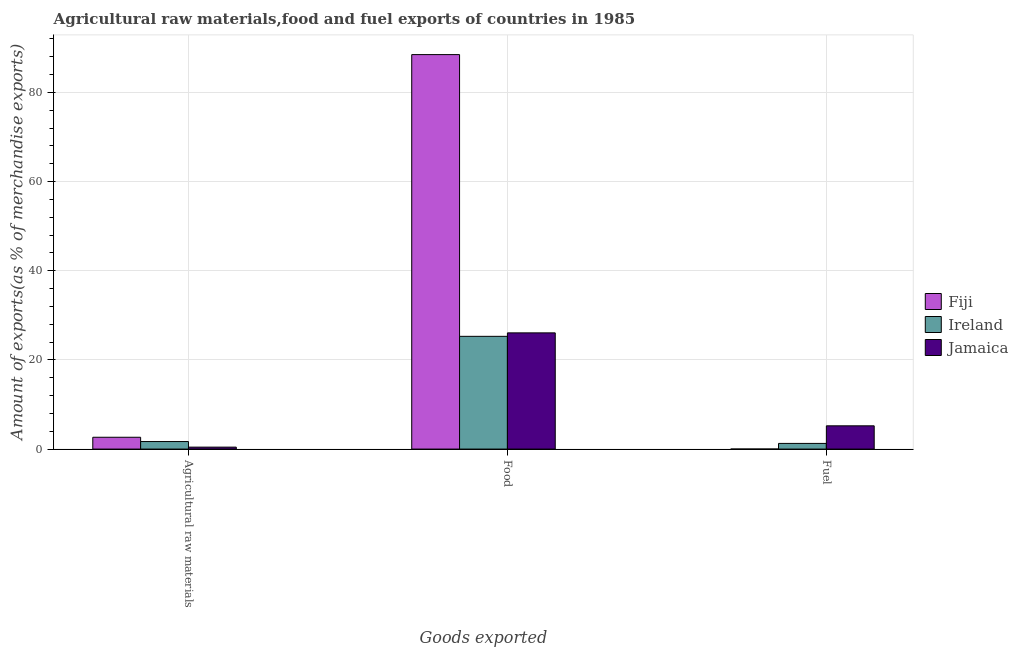How many different coloured bars are there?
Your answer should be compact. 3. How many groups of bars are there?
Offer a terse response. 3. Are the number of bars per tick equal to the number of legend labels?
Ensure brevity in your answer.  Yes. How many bars are there on the 3rd tick from the left?
Your response must be concise. 3. What is the label of the 3rd group of bars from the left?
Provide a short and direct response. Fuel. What is the percentage of raw materials exports in Jamaica?
Your response must be concise. 0.44. Across all countries, what is the maximum percentage of fuel exports?
Your answer should be compact. 5.22. Across all countries, what is the minimum percentage of fuel exports?
Offer a terse response. 0. In which country was the percentage of food exports maximum?
Make the answer very short. Fiji. In which country was the percentage of raw materials exports minimum?
Give a very brief answer. Jamaica. What is the total percentage of fuel exports in the graph?
Keep it short and to the point. 6.49. What is the difference between the percentage of raw materials exports in Jamaica and that in Ireland?
Make the answer very short. -1.26. What is the difference between the percentage of fuel exports in Ireland and the percentage of raw materials exports in Fiji?
Ensure brevity in your answer.  -1.38. What is the average percentage of food exports per country?
Offer a terse response. 46.6. What is the difference between the percentage of raw materials exports and percentage of fuel exports in Ireland?
Provide a short and direct response. 0.42. In how many countries, is the percentage of raw materials exports greater than 8 %?
Ensure brevity in your answer.  0. What is the ratio of the percentage of raw materials exports in Ireland to that in Fiji?
Your answer should be compact. 0.64. Is the percentage of fuel exports in Fiji less than that in Ireland?
Make the answer very short. Yes. Is the difference between the percentage of food exports in Ireland and Fiji greater than the difference between the percentage of fuel exports in Ireland and Fiji?
Your answer should be compact. No. What is the difference between the highest and the second highest percentage of raw materials exports?
Offer a terse response. 0.96. What is the difference between the highest and the lowest percentage of food exports?
Your answer should be very brief. 63.18. What does the 2nd bar from the left in Agricultural raw materials represents?
Your response must be concise. Ireland. What does the 2nd bar from the right in Fuel represents?
Keep it short and to the point. Ireland. Are all the bars in the graph horizontal?
Provide a succinct answer. No. Are the values on the major ticks of Y-axis written in scientific E-notation?
Provide a succinct answer. No. Does the graph contain any zero values?
Offer a very short reply. No. How many legend labels are there?
Make the answer very short. 3. How are the legend labels stacked?
Offer a very short reply. Vertical. What is the title of the graph?
Provide a short and direct response. Agricultural raw materials,food and fuel exports of countries in 1985. Does "Argentina" appear as one of the legend labels in the graph?
Provide a short and direct response. No. What is the label or title of the X-axis?
Your answer should be compact. Goods exported. What is the label or title of the Y-axis?
Provide a succinct answer. Amount of exports(as % of merchandise exports). What is the Amount of exports(as % of merchandise exports) of Fiji in Agricultural raw materials?
Provide a succinct answer. 2.65. What is the Amount of exports(as % of merchandise exports) in Ireland in Agricultural raw materials?
Make the answer very short. 1.69. What is the Amount of exports(as % of merchandise exports) of Jamaica in Agricultural raw materials?
Ensure brevity in your answer.  0.44. What is the Amount of exports(as % of merchandise exports) of Fiji in Food?
Provide a succinct answer. 88.47. What is the Amount of exports(as % of merchandise exports) of Ireland in Food?
Your response must be concise. 25.28. What is the Amount of exports(as % of merchandise exports) in Jamaica in Food?
Provide a short and direct response. 26.06. What is the Amount of exports(as % of merchandise exports) in Fiji in Fuel?
Ensure brevity in your answer.  0. What is the Amount of exports(as % of merchandise exports) in Ireland in Fuel?
Your response must be concise. 1.27. What is the Amount of exports(as % of merchandise exports) in Jamaica in Fuel?
Make the answer very short. 5.22. Across all Goods exported, what is the maximum Amount of exports(as % of merchandise exports) of Fiji?
Make the answer very short. 88.47. Across all Goods exported, what is the maximum Amount of exports(as % of merchandise exports) of Ireland?
Keep it short and to the point. 25.28. Across all Goods exported, what is the maximum Amount of exports(as % of merchandise exports) in Jamaica?
Provide a short and direct response. 26.06. Across all Goods exported, what is the minimum Amount of exports(as % of merchandise exports) of Fiji?
Provide a short and direct response. 0. Across all Goods exported, what is the minimum Amount of exports(as % of merchandise exports) in Ireland?
Your answer should be compact. 1.27. Across all Goods exported, what is the minimum Amount of exports(as % of merchandise exports) of Jamaica?
Provide a succinct answer. 0.44. What is the total Amount of exports(as % of merchandise exports) of Fiji in the graph?
Make the answer very short. 91.12. What is the total Amount of exports(as % of merchandise exports) of Ireland in the graph?
Keep it short and to the point. 28.24. What is the total Amount of exports(as % of merchandise exports) of Jamaica in the graph?
Keep it short and to the point. 31.71. What is the difference between the Amount of exports(as % of merchandise exports) in Fiji in Agricultural raw materials and that in Food?
Your response must be concise. -85.82. What is the difference between the Amount of exports(as % of merchandise exports) of Ireland in Agricultural raw materials and that in Food?
Your answer should be very brief. -23.59. What is the difference between the Amount of exports(as % of merchandise exports) of Jamaica in Agricultural raw materials and that in Food?
Your answer should be compact. -25.62. What is the difference between the Amount of exports(as % of merchandise exports) in Fiji in Agricultural raw materials and that in Fuel?
Ensure brevity in your answer.  2.65. What is the difference between the Amount of exports(as % of merchandise exports) of Ireland in Agricultural raw materials and that in Fuel?
Offer a very short reply. 0.42. What is the difference between the Amount of exports(as % of merchandise exports) in Jamaica in Agricultural raw materials and that in Fuel?
Offer a terse response. -4.78. What is the difference between the Amount of exports(as % of merchandise exports) in Fiji in Food and that in Fuel?
Give a very brief answer. 88.47. What is the difference between the Amount of exports(as % of merchandise exports) of Ireland in Food and that in Fuel?
Offer a terse response. 24.01. What is the difference between the Amount of exports(as % of merchandise exports) of Jamaica in Food and that in Fuel?
Provide a short and direct response. 20.84. What is the difference between the Amount of exports(as % of merchandise exports) of Fiji in Agricultural raw materials and the Amount of exports(as % of merchandise exports) of Ireland in Food?
Provide a succinct answer. -22.63. What is the difference between the Amount of exports(as % of merchandise exports) of Fiji in Agricultural raw materials and the Amount of exports(as % of merchandise exports) of Jamaica in Food?
Provide a succinct answer. -23.41. What is the difference between the Amount of exports(as % of merchandise exports) of Ireland in Agricultural raw materials and the Amount of exports(as % of merchandise exports) of Jamaica in Food?
Your answer should be compact. -24.37. What is the difference between the Amount of exports(as % of merchandise exports) in Fiji in Agricultural raw materials and the Amount of exports(as % of merchandise exports) in Ireland in Fuel?
Your answer should be compact. 1.38. What is the difference between the Amount of exports(as % of merchandise exports) of Fiji in Agricultural raw materials and the Amount of exports(as % of merchandise exports) of Jamaica in Fuel?
Offer a very short reply. -2.56. What is the difference between the Amount of exports(as % of merchandise exports) in Ireland in Agricultural raw materials and the Amount of exports(as % of merchandise exports) in Jamaica in Fuel?
Give a very brief answer. -3.52. What is the difference between the Amount of exports(as % of merchandise exports) in Fiji in Food and the Amount of exports(as % of merchandise exports) in Ireland in Fuel?
Make the answer very short. 87.2. What is the difference between the Amount of exports(as % of merchandise exports) of Fiji in Food and the Amount of exports(as % of merchandise exports) of Jamaica in Fuel?
Your response must be concise. 83.25. What is the difference between the Amount of exports(as % of merchandise exports) in Ireland in Food and the Amount of exports(as % of merchandise exports) in Jamaica in Fuel?
Ensure brevity in your answer.  20.07. What is the average Amount of exports(as % of merchandise exports) of Fiji per Goods exported?
Your answer should be compact. 30.37. What is the average Amount of exports(as % of merchandise exports) of Ireland per Goods exported?
Your answer should be compact. 9.41. What is the average Amount of exports(as % of merchandise exports) in Jamaica per Goods exported?
Your answer should be compact. 10.57. What is the difference between the Amount of exports(as % of merchandise exports) in Fiji and Amount of exports(as % of merchandise exports) in Ireland in Agricultural raw materials?
Offer a terse response. 0.96. What is the difference between the Amount of exports(as % of merchandise exports) of Fiji and Amount of exports(as % of merchandise exports) of Jamaica in Agricultural raw materials?
Offer a very short reply. 2.22. What is the difference between the Amount of exports(as % of merchandise exports) in Ireland and Amount of exports(as % of merchandise exports) in Jamaica in Agricultural raw materials?
Offer a terse response. 1.26. What is the difference between the Amount of exports(as % of merchandise exports) of Fiji and Amount of exports(as % of merchandise exports) of Ireland in Food?
Your answer should be compact. 63.18. What is the difference between the Amount of exports(as % of merchandise exports) in Fiji and Amount of exports(as % of merchandise exports) in Jamaica in Food?
Your answer should be very brief. 62.41. What is the difference between the Amount of exports(as % of merchandise exports) of Ireland and Amount of exports(as % of merchandise exports) of Jamaica in Food?
Offer a terse response. -0.78. What is the difference between the Amount of exports(as % of merchandise exports) of Fiji and Amount of exports(as % of merchandise exports) of Ireland in Fuel?
Offer a very short reply. -1.27. What is the difference between the Amount of exports(as % of merchandise exports) in Fiji and Amount of exports(as % of merchandise exports) in Jamaica in Fuel?
Provide a short and direct response. -5.21. What is the difference between the Amount of exports(as % of merchandise exports) of Ireland and Amount of exports(as % of merchandise exports) of Jamaica in Fuel?
Give a very brief answer. -3.95. What is the ratio of the Amount of exports(as % of merchandise exports) in Fiji in Agricultural raw materials to that in Food?
Your answer should be very brief. 0.03. What is the ratio of the Amount of exports(as % of merchandise exports) in Ireland in Agricultural raw materials to that in Food?
Make the answer very short. 0.07. What is the ratio of the Amount of exports(as % of merchandise exports) in Jamaica in Agricultural raw materials to that in Food?
Your answer should be compact. 0.02. What is the ratio of the Amount of exports(as % of merchandise exports) in Fiji in Agricultural raw materials to that in Fuel?
Your answer should be very brief. 2006.19. What is the ratio of the Amount of exports(as % of merchandise exports) of Ireland in Agricultural raw materials to that in Fuel?
Provide a succinct answer. 1.33. What is the ratio of the Amount of exports(as % of merchandise exports) of Jamaica in Agricultural raw materials to that in Fuel?
Provide a succinct answer. 0.08. What is the ratio of the Amount of exports(as % of merchandise exports) in Fiji in Food to that in Fuel?
Ensure brevity in your answer.  6.69e+04. What is the ratio of the Amount of exports(as % of merchandise exports) in Ireland in Food to that in Fuel?
Provide a short and direct response. 19.92. What is the ratio of the Amount of exports(as % of merchandise exports) in Jamaica in Food to that in Fuel?
Your response must be concise. 5. What is the difference between the highest and the second highest Amount of exports(as % of merchandise exports) of Fiji?
Give a very brief answer. 85.82. What is the difference between the highest and the second highest Amount of exports(as % of merchandise exports) in Ireland?
Make the answer very short. 23.59. What is the difference between the highest and the second highest Amount of exports(as % of merchandise exports) of Jamaica?
Ensure brevity in your answer.  20.84. What is the difference between the highest and the lowest Amount of exports(as % of merchandise exports) of Fiji?
Your answer should be compact. 88.47. What is the difference between the highest and the lowest Amount of exports(as % of merchandise exports) in Ireland?
Ensure brevity in your answer.  24.01. What is the difference between the highest and the lowest Amount of exports(as % of merchandise exports) in Jamaica?
Keep it short and to the point. 25.62. 